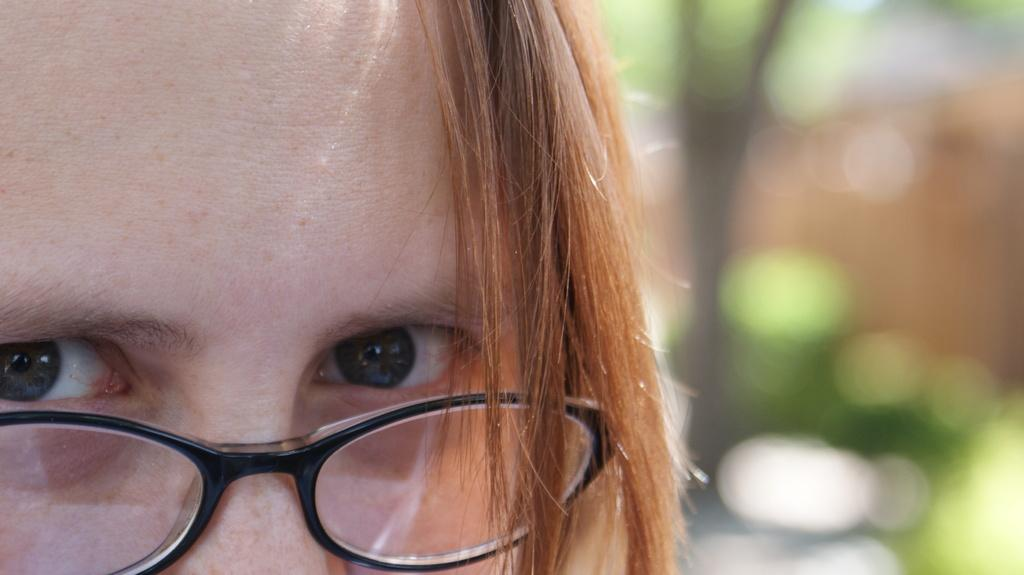What is the main subject of the image? The main subject of the image is a person's head. What can be seen on the person's face? The person is wearing black color spectacles. How would you describe the quality of the image on the right side? The right side of the image is blurred. Can you see any ocean waves in the image? There is no ocean or waves present in the image; it features a person's head with black color spectacles. What type of hair is visible on the person's head in the image? The image only shows the person's head from the forehead up, so it is not possible to determine the type of hair. 